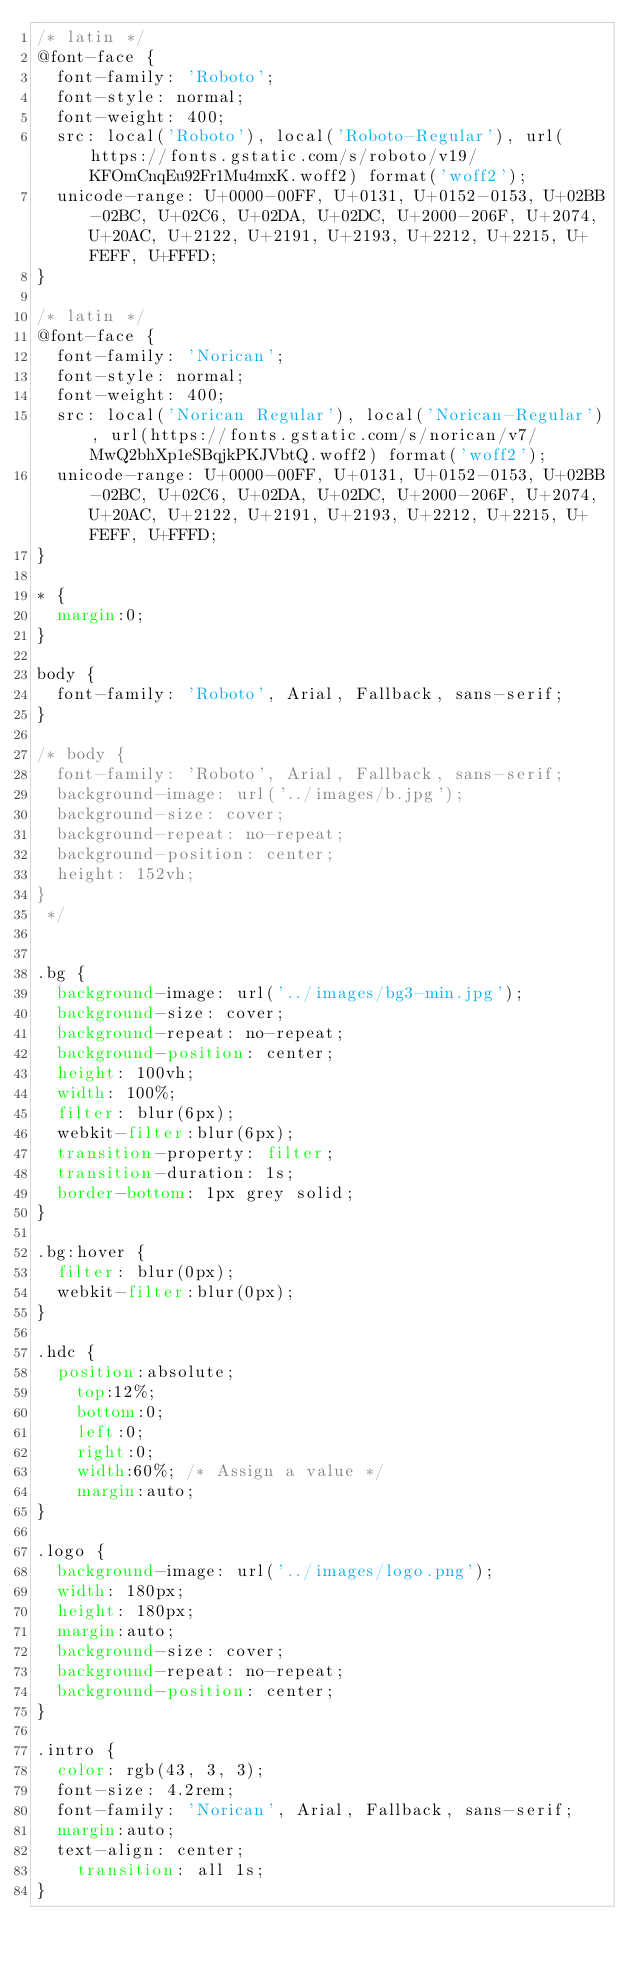<code> <loc_0><loc_0><loc_500><loc_500><_CSS_>/* latin */
@font-face {
  font-family: 'Roboto';
  font-style: normal;
  font-weight: 400;
  src: local('Roboto'), local('Roboto-Regular'), url(https://fonts.gstatic.com/s/roboto/v19/KFOmCnqEu92Fr1Mu4mxK.woff2) format('woff2');
  unicode-range: U+0000-00FF, U+0131, U+0152-0153, U+02BB-02BC, U+02C6, U+02DA, U+02DC, U+2000-206F, U+2074, U+20AC, U+2122, U+2191, U+2193, U+2212, U+2215, U+FEFF, U+FFFD;
}

/* latin */
@font-face {
  font-family: 'Norican';
  font-style: normal;
  font-weight: 400;
  src: local('Norican Regular'), local('Norican-Regular'), url(https://fonts.gstatic.com/s/norican/v7/MwQ2bhXp1eSBqjkPKJVbtQ.woff2) format('woff2');
  unicode-range: U+0000-00FF, U+0131, U+0152-0153, U+02BB-02BC, U+02C6, U+02DA, U+02DC, U+2000-206F, U+2074, U+20AC, U+2122, U+2191, U+2193, U+2212, U+2215, U+FEFF, U+FFFD;
}

* {
	margin:0;
}

body {
	font-family: 'Roboto', Arial, Fallback, sans-serif;
}

/* body {
	font-family: 'Roboto', Arial, Fallback, sans-serif;
	background-image: url('../images/b.jpg');
	background-size: cover;
	background-repeat: no-repeat;
	background-position: center;
	height: 152vh;
}
 */


.bg {
	background-image: url('../images/bg3-min.jpg');
	background-size: cover;
	background-repeat: no-repeat;
	background-position: center;
	height: 100vh;
	width: 100%;
	filter: blur(6px);
	webkit-filter:blur(6px);
	transition-property: filter;
	transition-duration: 1s;
	border-bottom: 1px grey solid;
}

.bg:hover {
	filter: blur(0px);
	webkit-filter:blur(0px);
}

.hdc {	
	position:absolute;
    top:12%;
    bottom:0;
    left:0;
    right:0;
    width:60%; /* Assign a value */
    margin:auto;
}

.logo {
	background-image: url('../images/logo.png');
	width: 180px;
	height: 180px;
	margin:auto;
	background-size: cover;
	background-repeat: no-repeat;
	background-position: center;
}

.intro {
	color: rgb(43, 3, 3);
	font-size: 4.2rem;
	font-family: 'Norican', Arial, Fallback, sans-serif;
	margin:auto;
	text-align: center;
    transition: all 1s;
}
</code> 